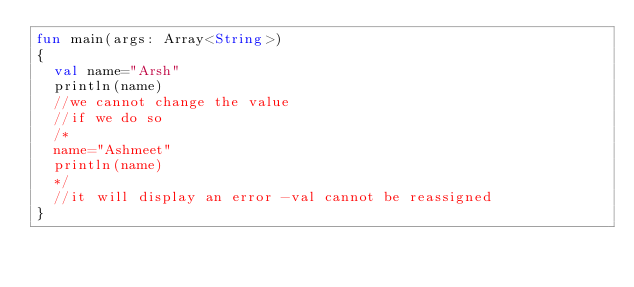Convert code to text. <code><loc_0><loc_0><loc_500><loc_500><_Kotlin_>fun main(args: Array<String>)
{
  val name="Arsh"
  println(name)
  //we cannot change the value
  //if we do so
  /*
  name="Ashmeet"
  println(name)
  */
  //it will display an error -val cannot be reassigned
}
</code> 